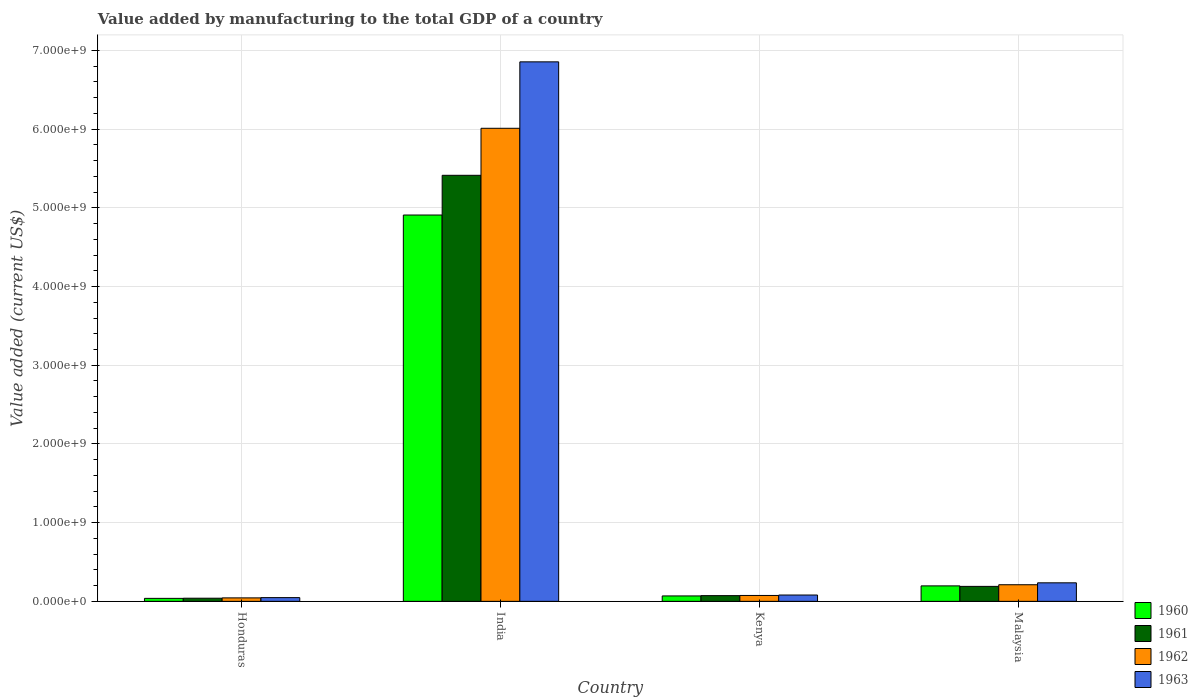How many different coloured bars are there?
Keep it short and to the point. 4. How many groups of bars are there?
Offer a terse response. 4. Are the number of bars per tick equal to the number of legend labels?
Offer a very short reply. Yes. What is the label of the 1st group of bars from the left?
Offer a terse response. Honduras. In how many cases, is the number of bars for a given country not equal to the number of legend labels?
Offer a terse response. 0. What is the value added by manufacturing to the total GDP in 1963 in Malaysia?
Offer a terse response. 2.36e+08. Across all countries, what is the maximum value added by manufacturing to the total GDP in 1962?
Your answer should be compact. 6.01e+09. Across all countries, what is the minimum value added by manufacturing to the total GDP in 1961?
Your answer should be compact. 4.00e+07. In which country was the value added by manufacturing to the total GDP in 1962 maximum?
Make the answer very short. India. In which country was the value added by manufacturing to the total GDP in 1960 minimum?
Provide a short and direct response. Honduras. What is the total value added by manufacturing to the total GDP in 1960 in the graph?
Provide a short and direct response. 5.21e+09. What is the difference between the value added by manufacturing to the total GDP in 1960 in India and that in Kenya?
Provide a succinct answer. 4.84e+09. What is the difference between the value added by manufacturing to the total GDP in 1961 in India and the value added by manufacturing to the total GDP in 1963 in Honduras?
Your answer should be compact. 5.37e+09. What is the average value added by manufacturing to the total GDP in 1963 per country?
Provide a short and direct response. 1.80e+09. What is the difference between the value added by manufacturing to the total GDP of/in 1960 and value added by manufacturing to the total GDP of/in 1962 in Kenya?
Provide a succinct answer. -5.94e+06. What is the ratio of the value added by manufacturing to the total GDP in 1961 in Kenya to that in Malaysia?
Your answer should be compact. 0.38. Is the difference between the value added by manufacturing to the total GDP in 1960 in Honduras and Malaysia greater than the difference between the value added by manufacturing to the total GDP in 1962 in Honduras and Malaysia?
Give a very brief answer. Yes. What is the difference between the highest and the second highest value added by manufacturing to the total GDP in 1963?
Your answer should be compact. 6.77e+09. What is the difference between the highest and the lowest value added by manufacturing to the total GDP in 1961?
Your answer should be very brief. 5.37e+09. Is it the case that in every country, the sum of the value added by manufacturing to the total GDP in 1963 and value added by manufacturing to the total GDP in 1960 is greater than the sum of value added by manufacturing to the total GDP in 1962 and value added by manufacturing to the total GDP in 1961?
Provide a short and direct response. No. What does the 3rd bar from the left in India represents?
Offer a terse response. 1962. Is it the case that in every country, the sum of the value added by manufacturing to the total GDP in 1962 and value added by manufacturing to the total GDP in 1960 is greater than the value added by manufacturing to the total GDP in 1961?
Your answer should be compact. Yes. How many bars are there?
Offer a terse response. 16. Are all the bars in the graph horizontal?
Give a very brief answer. No. Does the graph contain grids?
Your answer should be very brief. Yes. Where does the legend appear in the graph?
Provide a succinct answer. Bottom right. How many legend labels are there?
Keep it short and to the point. 4. What is the title of the graph?
Give a very brief answer. Value added by manufacturing to the total GDP of a country. What is the label or title of the X-axis?
Ensure brevity in your answer.  Country. What is the label or title of the Y-axis?
Ensure brevity in your answer.  Value added (current US$). What is the Value added (current US$) in 1960 in Honduras?
Your response must be concise. 3.80e+07. What is the Value added (current US$) in 1961 in Honduras?
Your answer should be compact. 4.00e+07. What is the Value added (current US$) of 1962 in Honduras?
Provide a short and direct response. 4.41e+07. What is the Value added (current US$) of 1963 in Honduras?
Offer a terse response. 4.76e+07. What is the Value added (current US$) of 1960 in India?
Ensure brevity in your answer.  4.91e+09. What is the Value added (current US$) in 1961 in India?
Keep it short and to the point. 5.41e+09. What is the Value added (current US$) in 1962 in India?
Offer a terse response. 6.01e+09. What is the Value added (current US$) in 1963 in India?
Keep it short and to the point. 6.85e+09. What is the Value added (current US$) in 1960 in Kenya?
Ensure brevity in your answer.  6.89e+07. What is the Value added (current US$) of 1961 in Kenya?
Provide a succinct answer. 7.28e+07. What is the Value added (current US$) of 1962 in Kenya?
Give a very brief answer. 7.48e+07. What is the Value added (current US$) in 1963 in Kenya?
Keep it short and to the point. 8.05e+07. What is the Value added (current US$) in 1960 in Malaysia?
Your answer should be very brief. 1.97e+08. What is the Value added (current US$) of 1961 in Malaysia?
Make the answer very short. 1.90e+08. What is the Value added (current US$) in 1962 in Malaysia?
Your answer should be compact. 2.11e+08. What is the Value added (current US$) in 1963 in Malaysia?
Your answer should be compact. 2.36e+08. Across all countries, what is the maximum Value added (current US$) in 1960?
Provide a succinct answer. 4.91e+09. Across all countries, what is the maximum Value added (current US$) in 1961?
Offer a terse response. 5.41e+09. Across all countries, what is the maximum Value added (current US$) in 1962?
Your answer should be compact. 6.01e+09. Across all countries, what is the maximum Value added (current US$) in 1963?
Give a very brief answer. 6.85e+09. Across all countries, what is the minimum Value added (current US$) in 1960?
Give a very brief answer. 3.80e+07. Across all countries, what is the minimum Value added (current US$) of 1961?
Your response must be concise. 4.00e+07. Across all countries, what is the minimum Value added (current US$) in 1962?
Your answer should be very brief. 4.41e+07. Across all countries, what is the minimum Value added (current US$) of 1963?
Give a very brief answer. 4.76e+07. What is the total Value added (current US$) of 1960 in the graph?
Your answer should be compact. 5.21e+09. What is the total Value added (current US$) of 1961 in the graph?
Keep it short and to the point. 5.72e+09. What is the total Value added (current US$) in 1962 in the graph?
Your answer should be very brief. 6.34e+09. What is the total Value added (current US$) in 1963 in the graph?
Your answer should be very brief. 7.22e+09. What is the difference between the Value added (current US$) of 1960 in Honduras and that in India?
Provide a succinct answer. -4.87e+09. What is the difference between the Value added (current US$) in 1961 in Honduras and that in India?
Ensure brevity in your answer.  -5.37e+09. What is the difference between the Value added (current US$) in 1962 in Honduras and that in India?
Give a very brief answer. -5.97e+09. What is the difference between the Value added (current US$) in 1963 in Honduras and that in India?
Your answer should be compact. -6.81e+09. What is the difference between the Value added (current US$) in 1960 in Honduras and that in Kenya?
Offer a terse response. -3.09e+07. What is the difference between the Value added (current US$) of 1961 in Honduras and that in Kenya?
Your answer should be very brief. -3.28e+07. What is the difference between the Value added (current US$) of 1962 in Honduras and that in Kenya?
Your answer should be very brief. -3.07e+07. What is the difference between the Value added (current US$) in 1963 in Honduras and that in Kenya?
Provide a succinct answer. -3.30e+07. What is the difference between the Value added (current US$) of 1960 in Honduras and that in Malaysia?
Ensure brevity in your answer.  -1.59e+08. What is the difference between the Value added (current US$) of 1961 in Honduras and that in Malaysia?
Offer a terse response. -1.50e+08. What is the difference between the Value added (current US$) in 1962 in Honduras and that in Malaysia?
Offer a terse response. -1.67e+08. What is the difference between the Value added (current US$) in 1963 in Honduras and that in Malaysia?
Your answer should be compact. -1.88e+08. What is the difference between the Value added (current US$) in 1960 in India and that in Kenya?
Provide a succinct answer. 4.84e+09. What is the difference between the Value added (current US$) of 1961 in India and that in Kenya?
Give a very brief answer. 5.34e+09. What is the difference between the Value added (current US$) of 1962 in India and that in Kenya?
Keep it short and to the point. 5.94e+09. What is the difference between the Value added (current US$) of 1963 in India and that in Kenya?
Ensure brevity in your answer.  6.77e+09. What is the difference between the Value added (current US$) in 1960 in India and that in Malaysia?
Keep it short and to the point. 4.71e+09. What is the difference between the Value added (current US$) in 1961 in India and that in Malaysia?
Provide a short and direct response. 5.22e+09. What is the difference between the Value added (current US$) of 1962 in India and that in Malaysia?
Provide a succinct answer. 5.80e+09. What is the difference between the Value added (current US$) of 1963 in India and that in Malaysia?
Make the answer very short. 6.62e+09. What is the difference between the Value added (current US$) in 1960 in Kenya and that in Malaysia?
Provide a short and direct response. -1.28e+08. What is the difference between the Value added (current US$) of 1961 in Kenya and that in Malaysia?
Provide a short and direct response. -1.18e+08. What is the difference between the Value added (current US$) of 1962 in Kenya and that in Malaysia?
Provide a short and direct response. -1.36e+08. What is the difference between the Value added (current US$) in 1963 in Kenya and that in Malaysia?
Offer a very short reply. -1.55e+08. What is the difference between the Value added (current US$) in 1960 in Honduras and the Value added (current US$) in 1961 in India?
Offer a very short reply. -5.38e+09. What is the difference between the Value added (current US$) of 1960 in Honduras and the Value added (current US$) of 1962 in India?
Offer a very short reply. -5.97e+09. What is the difference between the Value added (current US$) in 1960 in Honduras and the Value added (current US$) in 1963 in India?
Make the answer very short. -6.82e+09. What is the difference between the Value added (current US$) in 1961 in Honduras and the Value added (current US$) in 1962 in India?
Your answer should be very brief. -5.97e+09. What is the difference between the Value added (current US$) of 1961 in Honduras and the Value added (current US$) of 1963 in India?
Give a very brief answer. -6.81e+09. What is the difference between the Value added (current US$) in 1962 in Honduras and the Value added (current US$) in 1963 in India?
Offer a very short reply. -6.81e+09. What is the difference between the Value added (current US$) of 1960 in Honduras and the Value added (current US$) of 1961 in Kenya?
Give a very brief answer. -3.48e+07. What is the difference between the Value added (current US$) in 1960 in Honduras and the Value added (current US$) in 1962 in Kenya?
Provide a succinct answer. -3.68e+07. What is the difference between the Value added (current US$) in 1960 in Honduras and the Value added (current US$) in 1963 in Kenya?
Give a very brief answer. -4.25e+07. What is the difference between the Value added (current US$) of 1961 in Honduras and the Value added (current US$) of 1962 in Kenya?
Make the answer very short. -3.48e+07. What is the difference between the Value added (current US$) in 1961 in Honduras and the Value added (current US$) in 1963 in Kenya?
Provide a short and direct response. -4.05e+07. What is the difference between the Value added (current US$) in 1962 in Honduras and the Value added (current US$) in 1963 in Kenya?
Your answer should be very brief. -3.64e+07. What is the difference between the Value added (current US$) of 1960 in Honduras and the Value added (current US$) of 1961 in Malaysia?
Keep it short and to the point. -1.52e+08. What is the difference between the Value added (current US$) in 1960 in Honduras and the Value added (current US$) in 1962 in Malaysia?
Offer a very short reply. -1.73e+08. What is the difference between the Value added (current US$) in 1960 in Honduras and the Value added (current US$) in 1963 in Malaysia?
Your answer should be compact. -1.97e+08. What is the difference between the Value added (current US$) in 1961 in Honduras and the Value added (current US$) in 1962 in Malaysia?
Provide a short and direct response. -1.71e+08. What is the difference between the Value added (current US$) in 1961 in Honduras and the Value added (current US$) in 1963 in Malaysia?
Offer a very short reply. -1.95e+08. What is the difference between the Value added (current US$) in 1962 in Honduras and the Value added (current US$) in 1963 in Malaysia?
Offer a very short reply. -1.91e+08. What is the difference between the Value added (current US$) of 1960 in India and the Value added (current US$) of 1961 in Kenya?
Offer a very short reply. 4.84e+09. What is the difference between the Value added (current US$) in 1960 in India and the Value added (current US$) in 1962 in Kenya?
Give a very brief answer. 4.83e+09. What is the difference between the Value added (current US$) in 1960 in India and the Value added (current US$) in 1963 in Kenya?
Give a very brief answer. 4.83e+09. What is the difference between the Value added (current US$) in 1961 in India and the Value added (current US$) in 1962 in Kenya?
Give a very brief answer. 5.34e+09. What is the difference between the Value added (current US$) in 1961 in India and the Value added (current US$) in 1963 in Kenya?
Your answer should be compact. 5.33e+09. What is the difference between the Value added (current US$) in 1962 in India and the Value added (current US$) in 1963 in Kenya?
Offer a terse response. 5.93e+09. What is the difference between the Value added (current US$) of 1960 in India and the Value added (current US$) of 1961 in Malaysia?
Provide a short and direct response. 4.72e+09. What is the difference between the Value added (current US$) of 1960 in India and the Value added (current US$) of 1962 in Malaysia?
Provide a succinct answer. 4.70e+09. What is the difference between the Value added (current US$) in 1960 in India and the Value added (current US$) in 1963 in Malaysia?
Your response must be concise. 4.67e+09. What is the difference between the Value added (current US$) in 1961 in India and the Value added (current US$) in 1962 in Malaysia?
Give a very brief answer. 5.20e+09. What is the difference between the Value added (current US$) in 1961 in India and the Value added (current US$) in 1963 in Malaysia?
Provide a short and direct response. 5.18e+09. What is the difference between the Value added (current US$) in 1962 in India and the Value added (current US$) in 1963 in Malaysia?
Your answer should be compact. 5.78e+09. What is the difference between the Value added (current US$) of 1960 in Kenya and the Value added (current US$) of 1961 in Malaysia?
Your answer should be very brief. -1.21e+08. What is the difference between the Value added (current US$) of 1960 in Kenya and the Value added (current US$) of 1962 in Malaysia?
Give a very brief answer. -1.42e+08. What is the difference between the Value added (current US$) in 1960 in Kenya and the Value added (current US$) in 1963 in Malaysia?
Your answer should be compact. -1.67e+08. What is the difference between the Value added (current US$) in 1961 in Kenya and the Value added (current US$) in 1962 in Malaysia?
Give a very brief answer. -1.38e+08. What is the difference between the Value added (current US$) in 1961 in Kenya and the Value added (current US$) in 1963 in Malaysia?
Provide a succinct answer. -1.63e+08. What is the difference between the Value added (current US$) in 1962 in Kenya and the Value added (current US$) in 1963 in Malaysia?
Keep it short and to the point. -1.61e+08. What is the average Value added (current US$) of 1960 per country?
Your answer should be compact. 1.30e+09. What is the average Value added (current US$) of 1961 per country?
Provide a succinct answer. 1.43e+09. What is the average Value added (current US$) of 1962 per country?
Your response must be concise. 1.59e+09. What is the average Value added (current US$) of 1963 per country?
Offer a terse response. 1.80e+09. What is the difference between the Value added (current US$) in 1960 and Value added (current US$) in 1961 in Honduras?
Your response must be concise. -2.00e+06. What is the difference between the Value added (current US$) of 1960 and Value added (current US$) of 1962 in Honduras?
Ensure brevity in your answer.  -6.05e+06. What is the difference between the Value added (current US$) in 1960 and Value added (current US$) in 1963 in Honduras?
Keep it short and to the point. -9.50e+06. What is the difference between the Value added (current US$) of 1961 and Value added (current US$) of 1962 in Honduras?
Your answer should be very brief. -4.05e+06. What is the difference between the Value added (current US$) of 1961 and Value added (current US$) of 1963 in Honduras?
Your response must be concise. -7.50e+06. What is the difference between the Value added (current US$) in 1962 and Value added (current US$) in 1963 in Honduras?
Make the answer very short. -3.45e+06. What is the difference between the Value added (current US$) of 1960 and Value added (current US$) of 1961 in India?
Keep it short and to the point. -5.05e+08. What is the difference between the Value added (current US$) in 1960 and Value added (current US$) in 1962 in India?
Provide a short and direct response. -1.10e+09. What is the difference between the Value added (current US$) in 1960 and Value added (current US$) in 1963 in India?
Your answer should be very brief. -1.95e+09. What is the difference between the Value added (current US$) in 1961 and Value added (current US$) in 1962 in India?
Keep it short and to the point. -5.97e+08. What is the difference between the Value added (current US$) in 1961 and Value added (current US$) in 1963 in India?
Your answer should be compact. -1.44e+09. What is the difference between the Value added (current US$) in 1962 and Value added (current US$) in 1963 in India?
Offer a terse response. -8.44e+08. What is the difference between the Value added (current US$) of 1960 and Value added (current US$) of 1961 in Kenya?
Keep it short and to the point. -3.93e+06. What is the difference between the Value added (current US$) in 1960 and Value added (current US$) in 1962 in Kenya?
Keep it short and to the point. -5.94e+06. What is the difference between the Value added (current US$) of 1960 and Value added (current US$) of 1963 in Kenya?
Provide a short and direct response. -1.16e+07. What is the difference between the Value added (current US$) in 1961 and Value added (current US$) in 1962 in Kenya?
Your answer should be very brief. -2.00e+06. What is the difference between the Value added (current US$) of 1961 and Value added (current US$) of 1963 in Kenya?
Offer a very short reply. -7.70e+06. What is the difference between the Value added (current US$) of 1962 and Value added (current US$) of 1963 in Kenya?
Offer a very short reply. -5.70e+06. What is the difference between the Value added (current US$) in 1960 and Value added (current US$) in 1961 in Malaysia?
Ensure brevity in your answer.  6.25e+06. What is the difference between the Value added (current US$) in 1960 and Value added (current US$) in 1962 in Malaysia?
Provide a short and direct response. -1.46e+07. What is the difference between the Value added (current US$) in 1960 and Value added (current US$) in 1963 in Malaysia?
Make the answer very short. -3.89e+07. What is the difference between the Value added (current US$) in 1961 and Value added (current US$) in 1962 in Malaysia?
Your response must be concise. -2.08e+07. What is the difference between the Value added (current US$) of 1961 and Value added (current US$) of 1963 in Malaysia?
Offer a very short reply. -4.52e+07. What is the difference between the Value added (current US$) of 1962 and Value added (current US$) of 1963 in Malaysia?
Give a very brief answer. -2.43e+07. What is the ratio of the Value added (current US$) of 1960 in Honduras to that in India?
Give a very brief answer. 0.01. What is the ratio of the Value added (current US$) in 1961 in Honduras to that in India?
Your answer should be compact. 0.01. What is the ratio of the Value added (current US$) in 1962 in Honduras to that in India?
Offer a very short reply. 0.01. What is the ratio of the Value added (current US$) in 1963 in Honduras to that in India?
Make the answer very short. 0.01. What is the ratio of the Value added (current US$) of 1960 in Honduras to that in Kenya?
Your answer should be very brief. 0.55. What is the ratio of the Value added (current US$) in 1961 in Honduras to that in Kenya?
Keep it short and to the point. 0.55. What is the ratio of the Value added (current US$) of 1962 in Honduras to that in Kenya?
Offer a terse response. 0.59. What is the ratio of the Value added (current US$) of 1963 in Honduras to that in Kenya?
Your answer should be compact. 0.59. What is the ratio of the Value added (current US$) in 1960 in Honduras to that in Malaysia?
Ensure brevity in your answer.  0.19. What is the ratio of the Value added (current US$) of 1961 in Honduras to that in Malaysia?
Offer a terse response. 0.21. What is the ratio of the Value added (current US$) of 1962 in Honduras to that in Malaysia?
Provide a short and direct response. 0.21. What is the ratio of the Value added (current US$) in 1963 in Honduras to that in Malaysia?
Keep it short and to the point. 0.2. What is the ratio of the Value added (current US$) in 1960 in India to that in Kenya?
Your response must be concise. 71.24. What is the ratio of the Value added (current US$) in 1961 in India to that in Kenya?
Ensure brevity in your answer.  74.32. What is the ratio of the Value added (current US$) of 1962 in India to that in Kenya?
Ensure brevity in your answer.  80.31. What is the ratio of the Value added (current US$) of 1963 in India to that in Kenya?
Your response must be concise. 85.11. What is the ratio of the Value added (current US$) in 1960 in India to that in Malaysia?
Your answer should be very brief. 24.96. What is the ratio of the Value added (current US$) in 1961 in India to that in Malaysia?
Your response must be concise. 28.44. What is the ratio of the Value added (current US$) in 1962 in India to that in Malaysia?
Your response must be concise. 28.46. What is the ratio of the Value added (current US$) in 1963 in India to that in Malaysia?
Your response must be concise. 29.1. What is the ratio of the Value added (current US$) of 1960 in Kenya to that in Malaysia?
Keep it short and to the point. 0.35. What is the ratio of the Value added (current US$) of 1961 in Kenya to that in Malaysia?
Your answer should be compact. 0.38. What is the ratio of the Value added (current US$) in 1962 in Kenya to that in Malaysia?
Your answer should be compact. 0.35. What is the ratio of the Value added (current US$) of 1963 in Kenya to that in Malaysia?
Offer a very short reply. 0.34. What is the difference between the highest and the second highest Value added (current US$) in 1960?
Make the answer very short. 4.71e+09. What is the difference between the highest and the second highest Value added (current US$) of 1961?
Your answer should be very brief. 5.22e+09. What is the difference between the highest and the second highest Value added (current US$) in 1962?
Offer a terse response. 5.80e+09. What is the difference between the highest and the second highest Value added (current US$) of 1963?
Your answer should be very brief. 6.62e+09. What is the difference between the highest and the lowest Value added (current US$) of 1960?
Keep it short and to the point. 4.87e+09. What is the difference between the highest and the lowest Value added (current US$) in 1961?
Offer a terse response. 5.37e+09. What is the difference between the highest and the lowest Value added (current US$) of 1962?
Your answer should be compact. 5.97e+09. What is the difference between the highest and the lowest Value added (current US$) in 1963?
Offer a very short reply. 6.81e+09. 